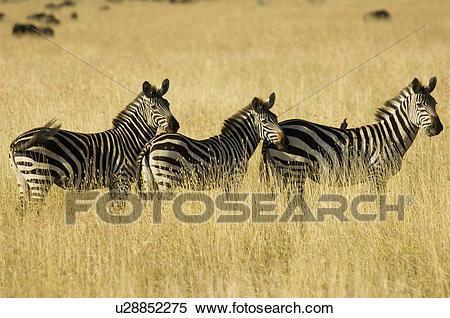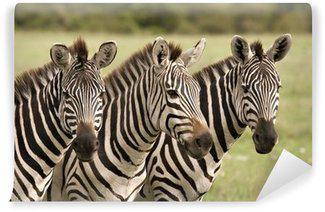The first image is the image on the left, the second image is the image on the right. Assess this claim about the two images: "Three zebras are nicely lined up in both of the pictures.". Correct or not? Answer yes or no. Yes. 